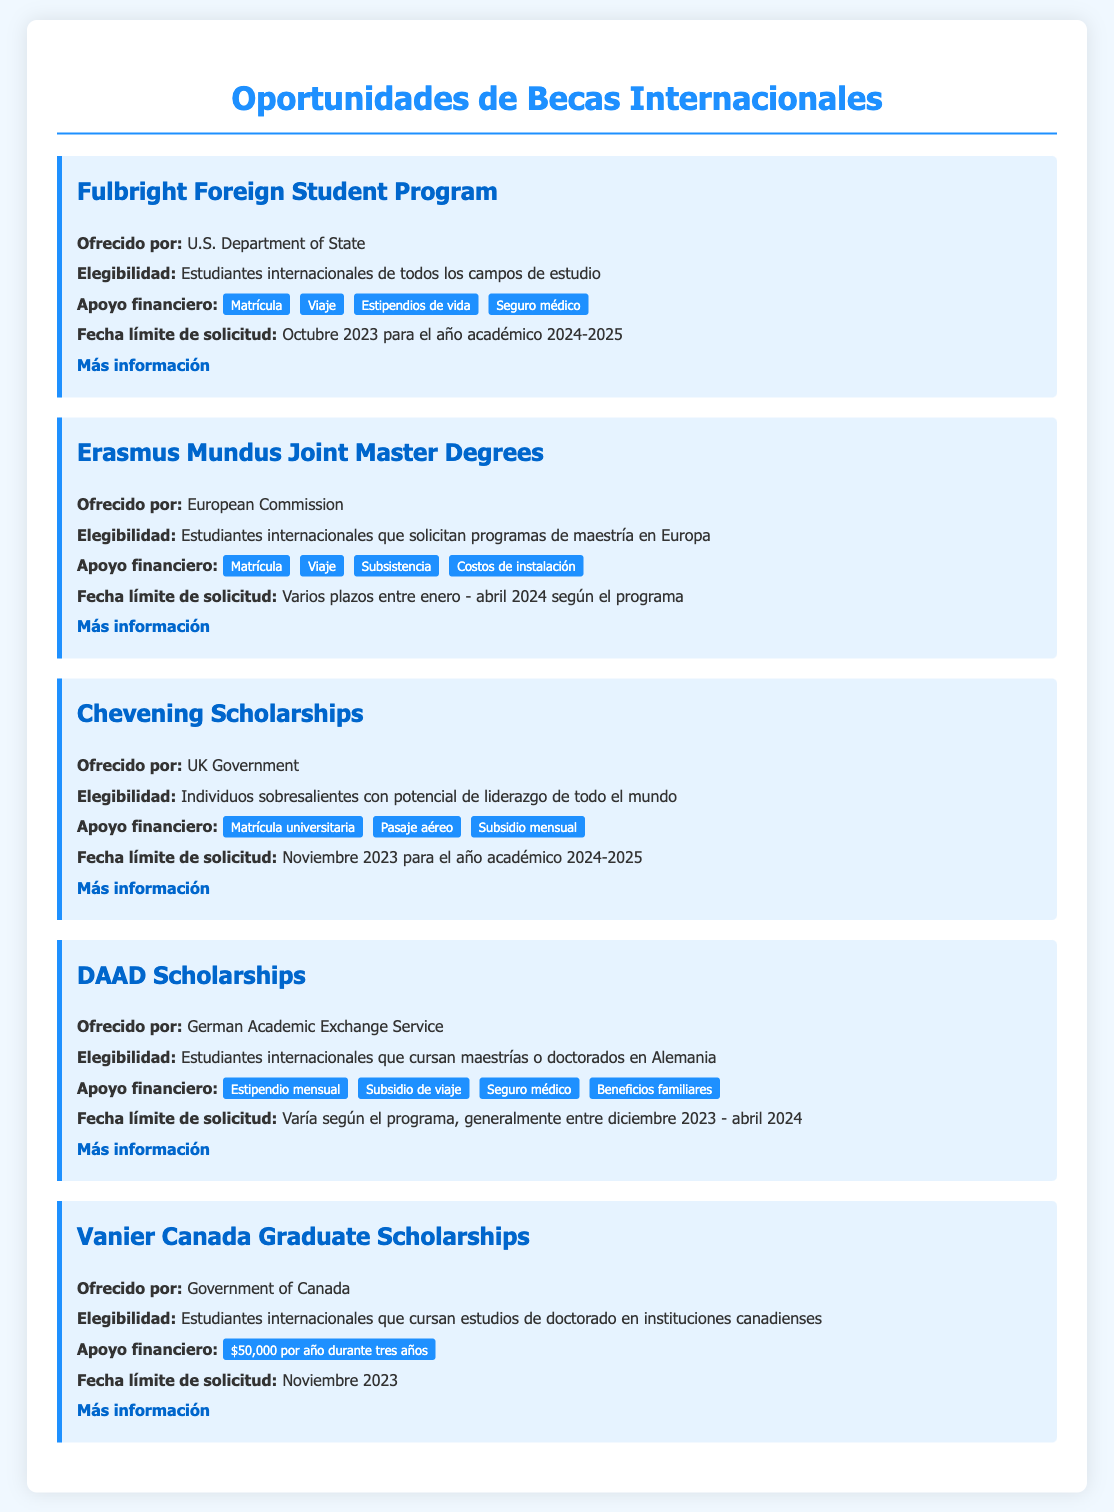¿Cuál es el nombre del programa de becas ofrecido por el Departamento de Estado de EE. UU.? El documento menciona el "Programa de Estudiantes Extranjeros Fulbright".
Answer: Programa de Estudiantes Extranjeros Fulbright ¿Cuál es la fecha límite de solicitud para las becas Chevening? Según el documento, la fecha límite de solicitud es en noviembre de 2023.
Answer: Noviembre 2023 ¿Qué tipo de apoyo financiero se ofrece a través de las Becas DAAD? El documento enumera "Estipendio mensual", "Subsidio de viaje", "Seguro médico" y "Beneficios familiares".
Answer: Estipendio mensual, Subsidio de viaje, Seguro médico, Beneficios familiares ¿Quién es elegible para las Becas Erasmus Mundus? La elegibilidad se especifica como estudiantes internacionales que solicitan programas de maestría en Europa.
Answer: Estudiantes internacionales que solicitan programas de maestría en Europa ¿Cuál es el valor anual de las Becas Vanier de Canadá? El documento indica que el apoyo financiero es de "$50,000 por año durante tres años".
Answer: $50,000 por año ¿Cuándo se pueden presentar solicitudes para Erasmus Mundus? El documento aclara que hay varios plazos entre enero y abril de 2024 según el programa.
Answer: Varios plazos entre enero - abril 2024 ¿Qué características diferencian las becas Chevening de las becas Fulbright? Ambos programas ofrecen matrícula, pero Chevening incluye "Pasaje aéreo" y un "Subsidio mensual", mientras que Fulbright incluye "Estipendios de vida" y "Seguro médico".
Answer: Diferentes tipos de apoyo financiero ¿Cuáles son los beneficios incluidos en las Becas Fulbright? Se menciona que incluye matrícula, viaje, estipendios de vida y seguro médico.
Answer: Matrícula, viaje, estipendios de vida, seguro médico 